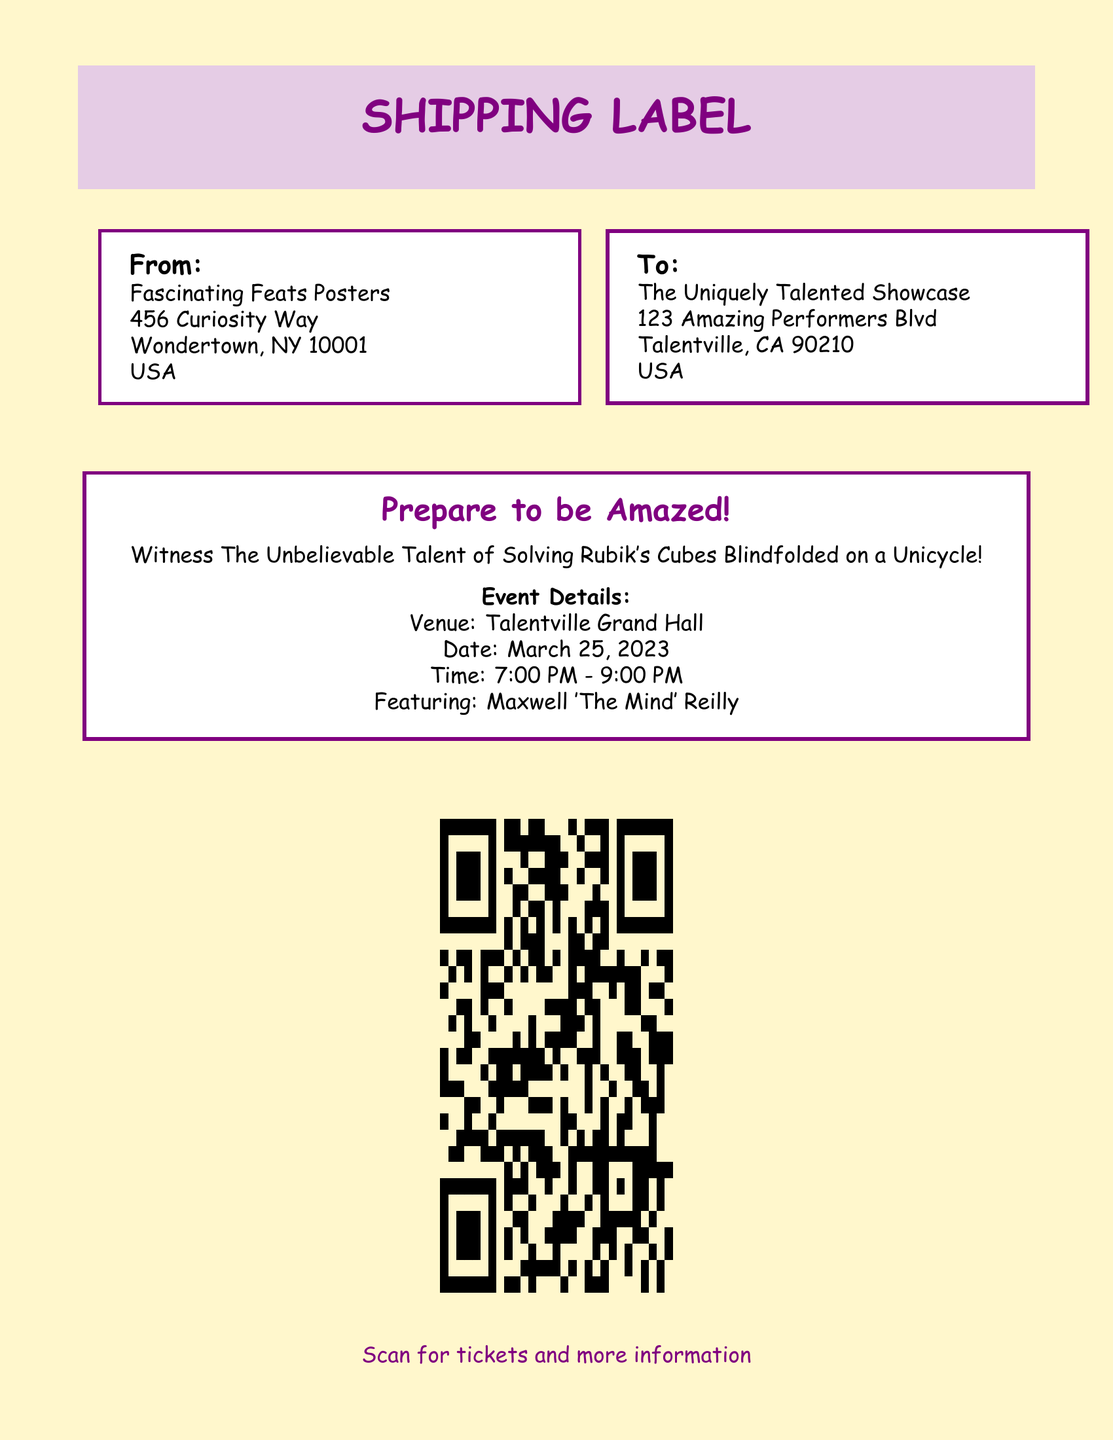What is the sender's name? The sender's name is listed in the document under "From" as Fascinating Feats Posters.
Answer: Fascinating Feats Posters What is the recipient's address? The recipient's address is provided under "To" in the document.
Answer: The Uniquely Talented Showcase, 123 Amazing Performers Blvd, Talentville, CA 90210, USA What date is the event scheduled for? The document specifies the date of the event in the event details as March 25, 2023.
Answer: March 25, 2023 What is the time range of the event? The time range for the event is stated in the document under "Time".
Answer: 7:00 PM - 9:00 PM Who is featured in the event? The featured talent is mentioned towards the end of the event details.
Answer: Maxwell 'The Mind' Reilly What type of talent is being showcased? The document describes the unique talent being showcased in the event details.
Answer: Solving Rubik's Cubes Blindfolded on a Unicycle What venue will host the event? The venue for the event is specified in the document.
Answer: Talentville Grand Hall What color is the background of the document? The document's background color is described in the code used to create it.
Answer: Unicycle yellow What can you scan for more information? The document indicates a QR code that links to more information.
Answer: Tickets and more information What is the tone of the event invitation? The language used in the document suggests a sense of excitement and anticipation.
Answer: Prepare to be Amazed! 